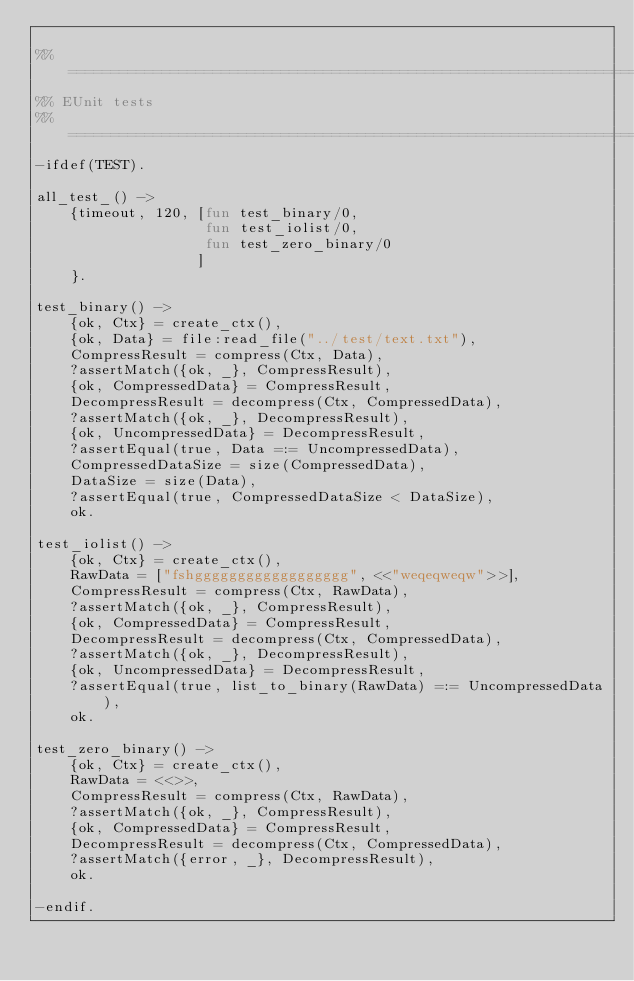<code> <loc_0><loc_0><loc_500><loc_500><_Erlang_>
%% ===================================================================
%% EUnit tests
%% ===================================================================
-ifdef(TEST).

all_test_() ->
    {timeout, 120, [fun test_binary/0,
                    fun test_iolist/0,
                    fun test_zero_binary/0
                   ]
    }.

test_binary() ->
    {ok, Ctx} = create_ctx(),
    {ok, Data} = file:read_file("../test/text.txt"),
    CompressResult = compress(Ctx, Data),
    ?assertMatch({ok, _}, CompressResult),
    {ok, CompressedData} = CompressResult,
    DecompressResult = decompress(Ctx, CompressedData),
    ?assertMatch({ok, _}, DecompressResult),
    {ok, UncompressedData} = DecompressResult,
    ?assertEqual(true, Data =:= UncompressedData),
    CompressedDataSize = size(CompressedData),
    DataSize = size(Data),
    ?assertEqual(true, CompressedDataSize < DataSize),
    ok.

test_iolist() ->
    {ok, Ctx} = create_ctx(),
    RawData = ["fshgggggggggggggggggg", <<"weqeqweqw">>],
    CompressResult = compress(Ctx, RawData),
    ?assertMatch({ok, _}, CompressResult),
    {ok, CompressedData} = CompressResult,
    DecompressResult = decompress(Ctx, CompressedData),
    ?assertMatch({ok, _}, DecompressResult),
    {ok, UncompressedData} = DecompressResult,
    ?assertEqual(true, list_to_binary(RawData) =:= UncompressedData),
    ok.

test_zero_binary() ->
    {ok, Ctx} = create_ctx(),
    RawData = <<>>,
    CompressResult = compress(Ctx, RawData),
    ?assertMatch({ok, _}, CompressResult),
    {ok, CompressedData} = CompressResult,
    DecompressResult = decompress(Ctx, CompressedData),
    ?assertMatch({error, _}, DecompressResult),
    ok.

-endif.
</code> 